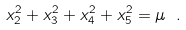Convert formula to latex. <formula><loc_0><loc_0><loc_500><loc_500>x _ { 2 } ^ { 2 } + x _ { 3 } ^ { 2 } + x _ { 4 } ^ { 2 } + x _ { 5 } ^ { 2 } = \mu \ .</formula> 